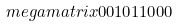<formula> <loc_0><loc_0><loc_500><loc_500>\ m e g a m a t r i x { 0 } { 0 } { 1 } { 0 } { 1 } { 1 } { 0 } { 0 } { 0 }</formula> 